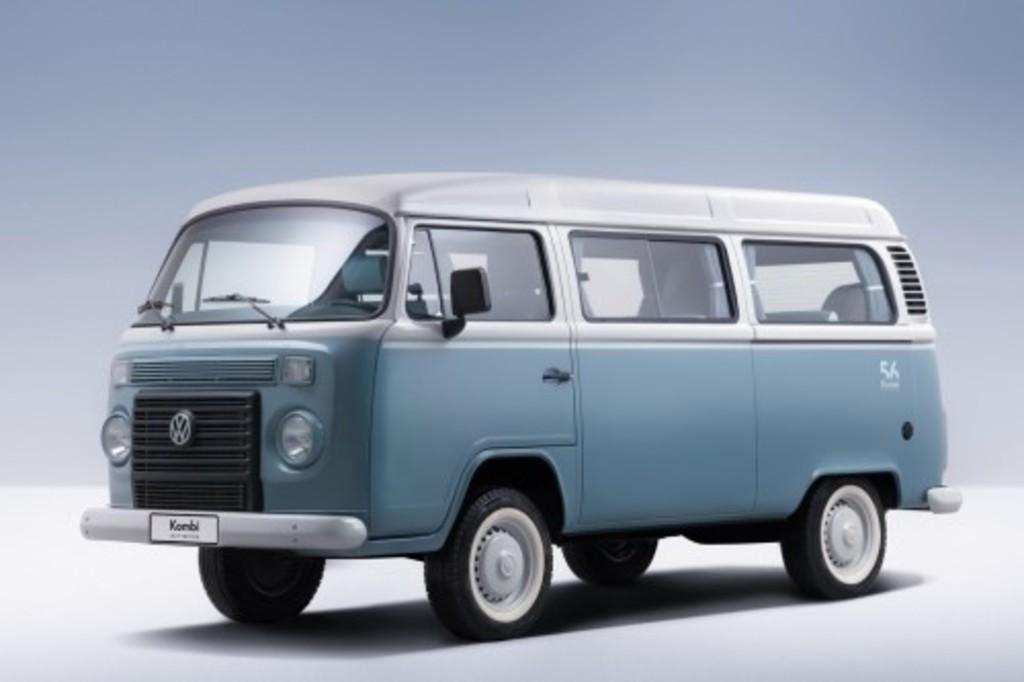<image>
Summarize the visual content of the image. Blue and white van with the license plate "Kombi". 